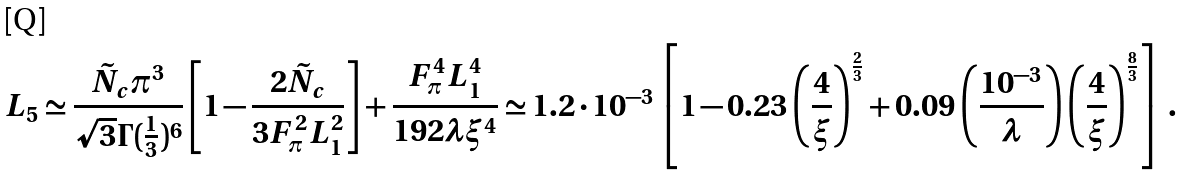<formula> <loc_0><loc_0><loc_500><loc_500>L _ { 5 } \simeq \frac { \tilde { N } _ { c } \pi ^ { 3 } } { \sqrt { 3 } \Gamma ( \frac { 1 } { 3 } ) ^ { 6 } } \left [ 1 - \frac { 2 \tilde { N } _ { c } } { 3 F ^ { 2 } _ { \pi } L _ { 1 } ^ { 2 } } \right ] + \frac { F ^ { 4 } _ { \pi } L _ { 1 } ^ { 4 } } { 1 9 2 \lambda \xi ^ { 4 } } \simeq 1 . 2 \cdot 1 0 ^ { - 3 } \left [ 1 - 0 . 2 3 \left ( \frac { 4 } { \xi } \right ) ^ { \frac { 2 } { 3 } } + 0 . 0 9 \left ( \frac { 1 0 ^ { - 3 } } { \lambda } \right ) \left ( \frac { 4 } { \xi } \right ) ^ { \frac { 8 } { 3 } } \right ] \, .</formula> 